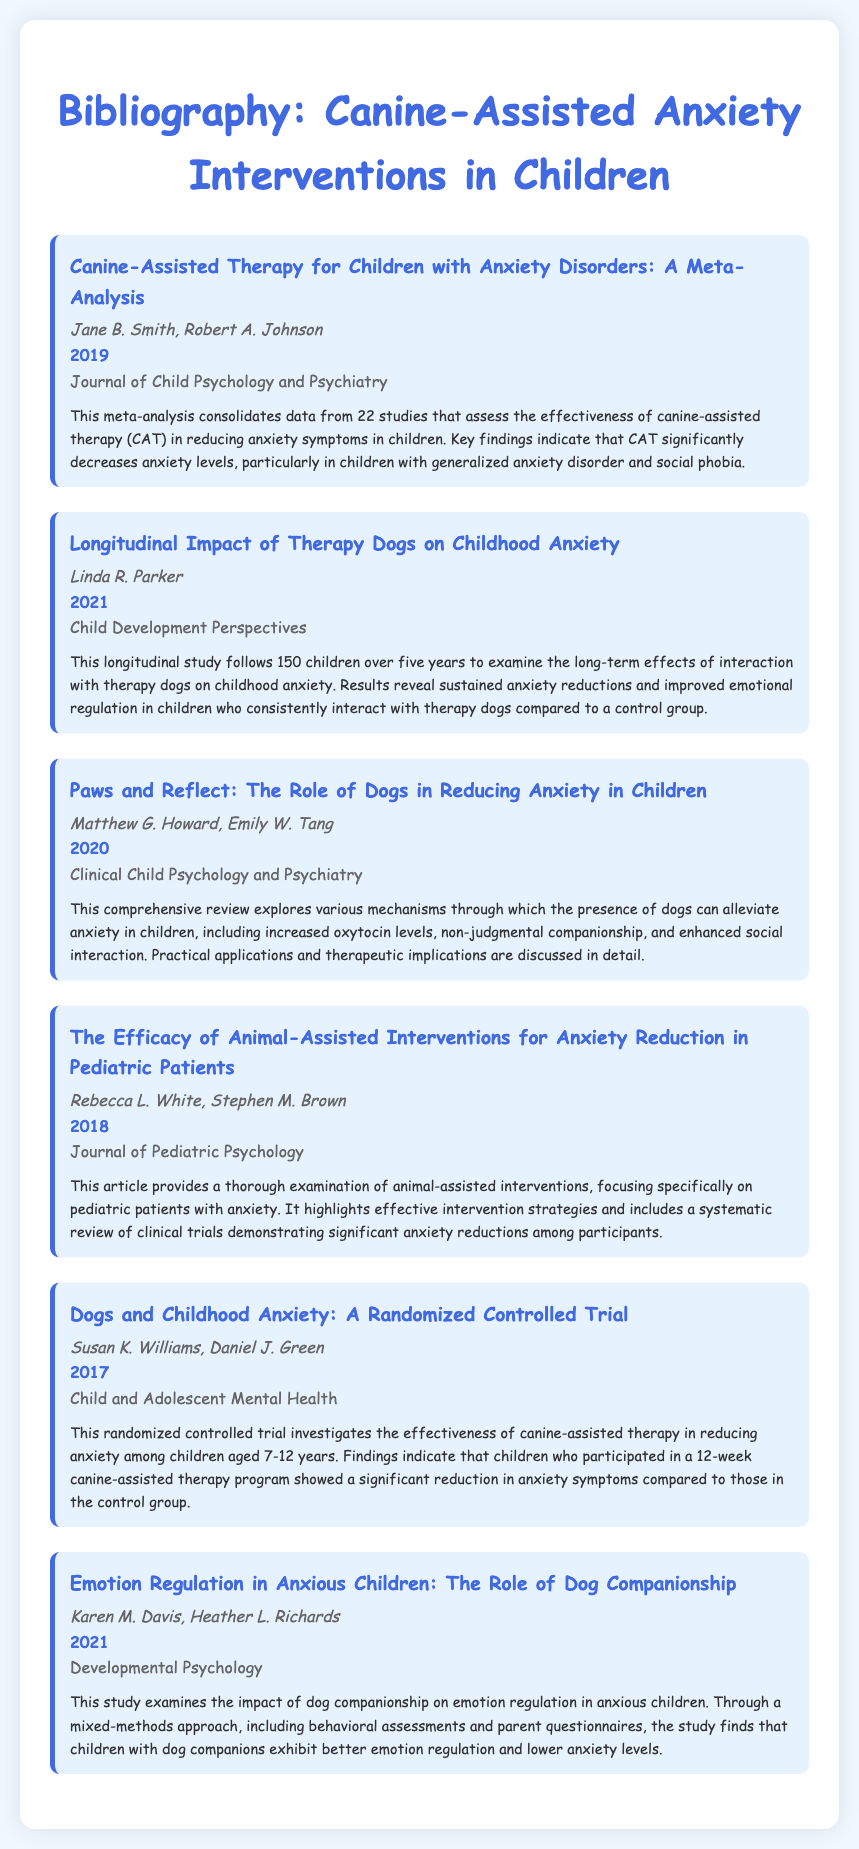What is the title of the first entry? The title of the first entry is specifically mentioned at the top of the first annotated bibliography entry.
Answer: Canine-Assisted Therapy for Children with Anxiety Disorders: A Meta-Analysis Who are the authors of the study published in 2021? The authors of the study published in 2021 are listed under that year's entry, allowing retrieval of the author's names.
Answer: Linda R. Parker What year was the randomized controlled trial published? The year of publication is noted with each entry, and for the randomized controlled trial, it's explicitly mentioned next to the title and authors.
Answer: 2017 What is the main focus of Rebecca L. White's article? The focus of the article can be found in the summary section of the respective entry.
Answer: Animal-assisted interventions How many studies were included in the meta-analysis? The total number of studies is specified in the summary of the first entry.
Answer: 22 What journal published the article on the role of dogs in reducing anxiety? The journal's name is mentioned clearly in each entry, indicating where the studies were published.
Answer: Clinical Child Psychology and Psychiatry Which study discusses the long-term effects of therapy dogs? The specific study focused on long-term effects is detailed in the summary of its respective entry.
Answer: Longitudinal Impact of Therapy Dogs on Childhood Anxiety What is the primary benefit highlighted for anxious children who have dog companions? The primary benefit can be inferred from the summaries of relevant studies within the document.
Answer: Better emotion regulation 